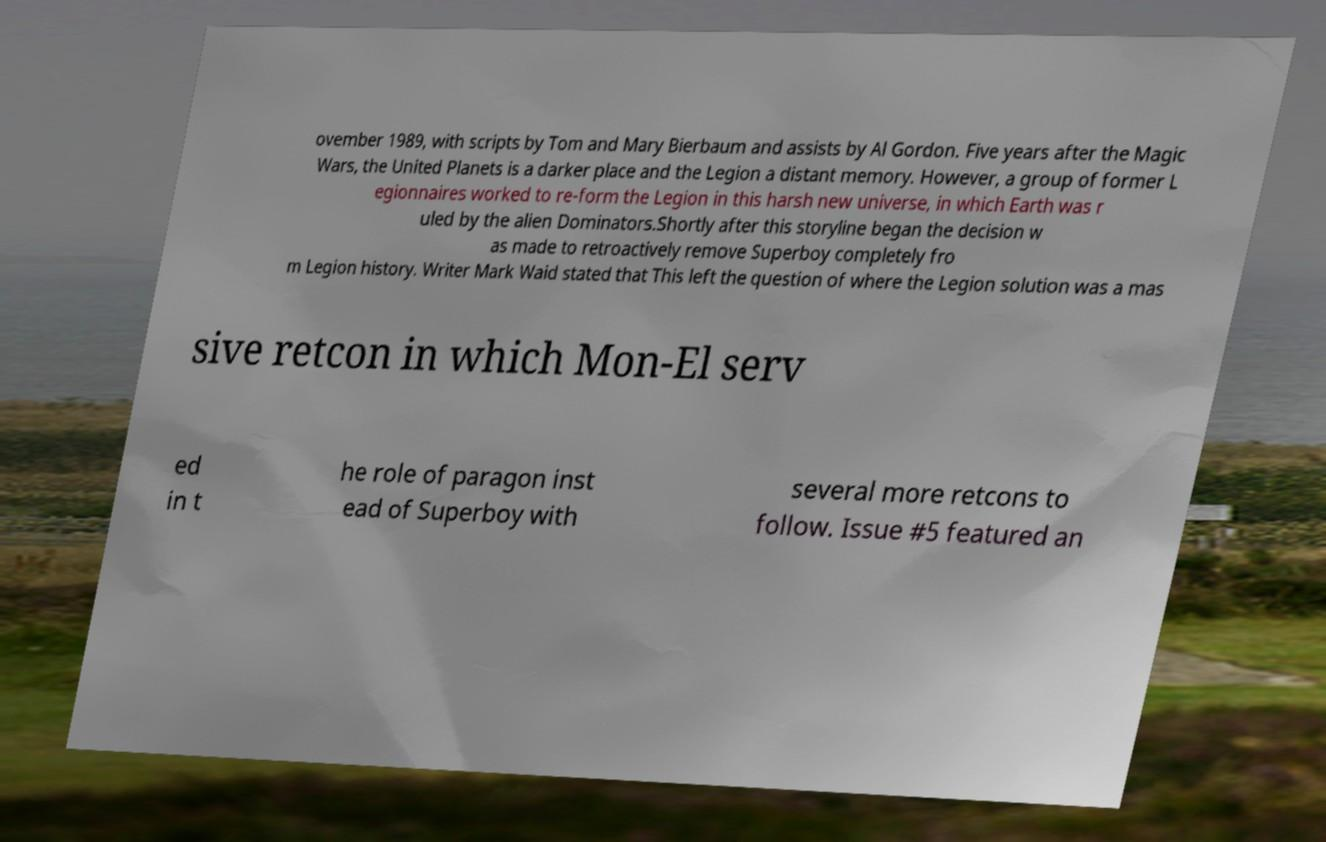Could you assist in decoding the text presented in this image and type it out clearly? ovember 1989, with scripts by Tom and Mary Bierbaum and assists by Al Gordon. Five years after the Magic Wars, the United Planets is a darker place and the Legion a distant memory. However, a group of former L egionnaires worked to re-form the Legion in this harsh new universe, in which Earth was r uled by the alien Dominators.Shortly after this storyline began the decision w as made to retroactively remove Superboy completely fro m Legion history. Writer Mark Waid stated that This left the question of where the Legion solution was a mas sive retcon in which Mon-El serv ed in t he role of paragon inst ead of Superboy with several more retcons to follow. Issue #5 featured an 